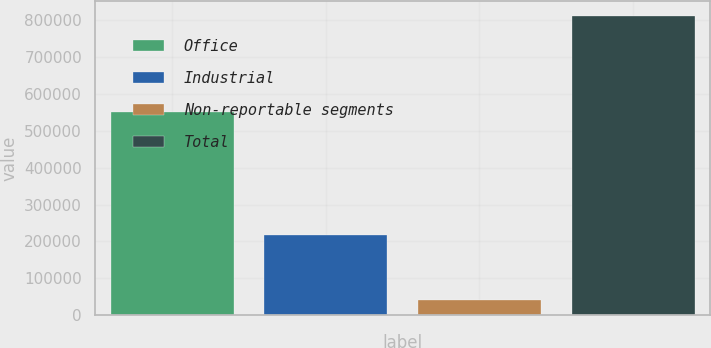Convert chart. <chart><loc_0><loc_0><loc_500><loc_500><bar_chart><fcel>Office<fcel>Industrial<fcel>Non-reportable segments<fcel>Total<nl><fcel>550116<fcel>218055<fcel>42376<fcel>810547<nl></chart> 